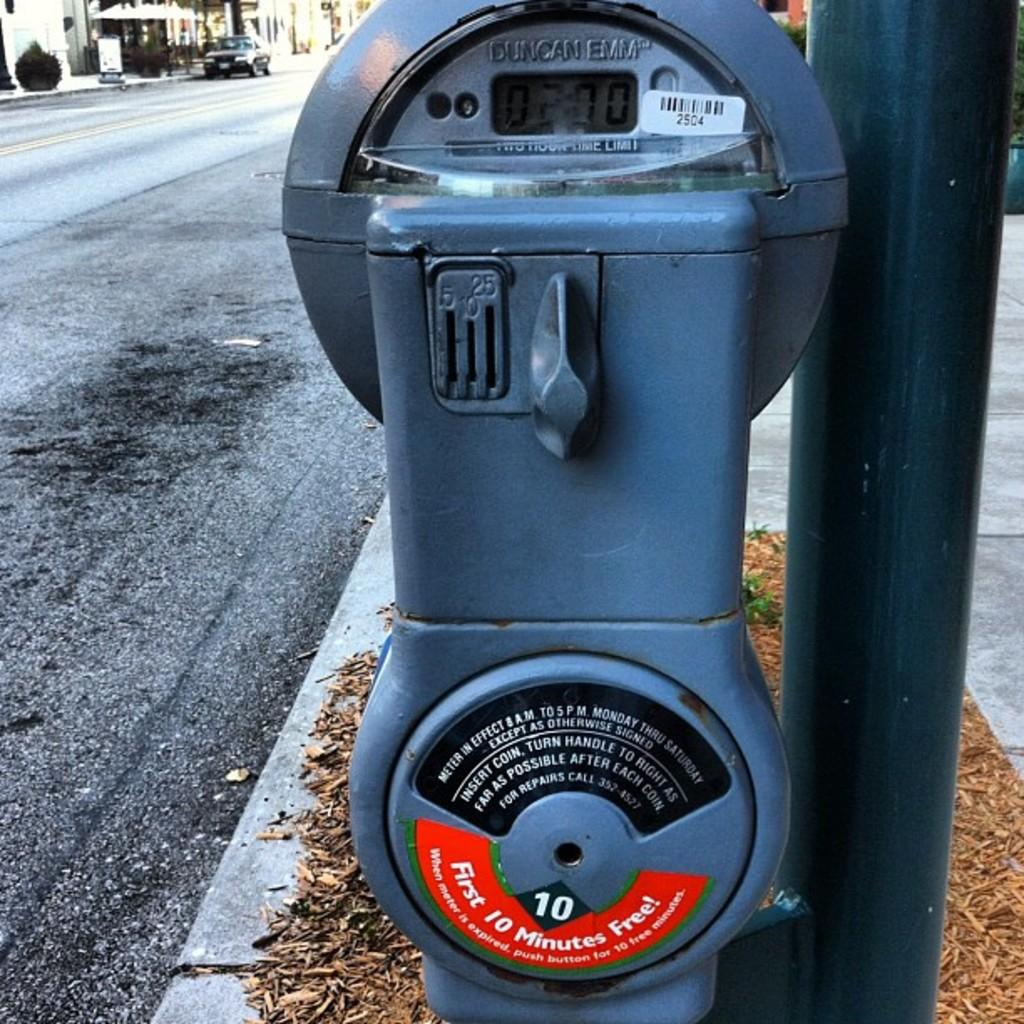<image>
Provide a brief description of the given image. A Duncan Emm parking meter with a two hour time limit. 